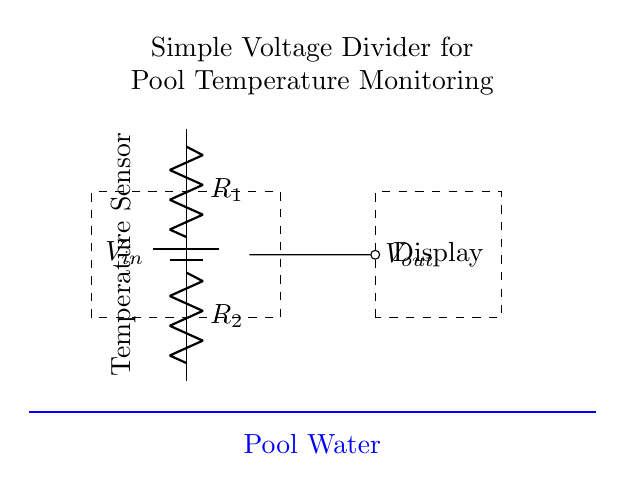What type of circuit is this? This circuit is a voltage divider, which consists of two resistors in series used to divide the input voltage.
Answer: voltage divider What is the role of the temperature sensor? The temperature sensor is used to measure the temperature of the pool water and is connected to the voltage divider to output a voltage proportional to the temperature.
Answer: measure temperature What components are present in this circuit? The circuit includes a battery, two resistors, a temperature sensor, and a display for showing the output voltage.
Answer: battery, resistors, sensor, display What is the output voltage represented as in this circuit? The output voltage is represented as Vout, which is the voltage across R2, indicating the fraction of Vin based on the values of R1 and R2.
Answer: Vout How does changing R1 affect Vout? Increasing R1 results in a decrease in Vout because it increases the total resistance, leading to a lower voltage across R2. This is based on the voltage divider formula.
Answer: decreases Vout What is the purpose of the battery in this circuit? The battery provides the input voltage for the voltage divider, allowing the circuit to function and measure the pool water temperature.
Answer: provide input voltage 